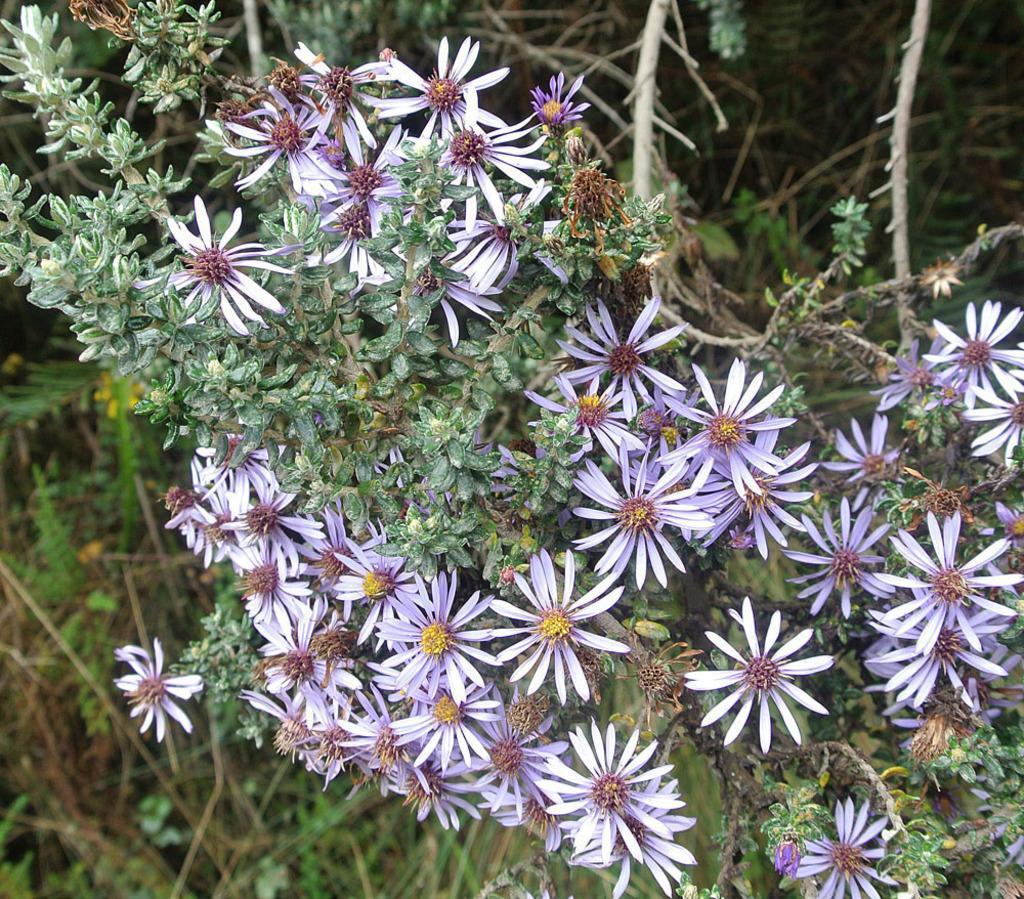How would you summarize this image in a sentence or two? In this image I can see few trees which are green and brown in color and to them I can see few flowers which are purple and yellow in color. 